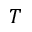<formula> <loc_0><loc_0><loc_500><loc_500>T</formula> 